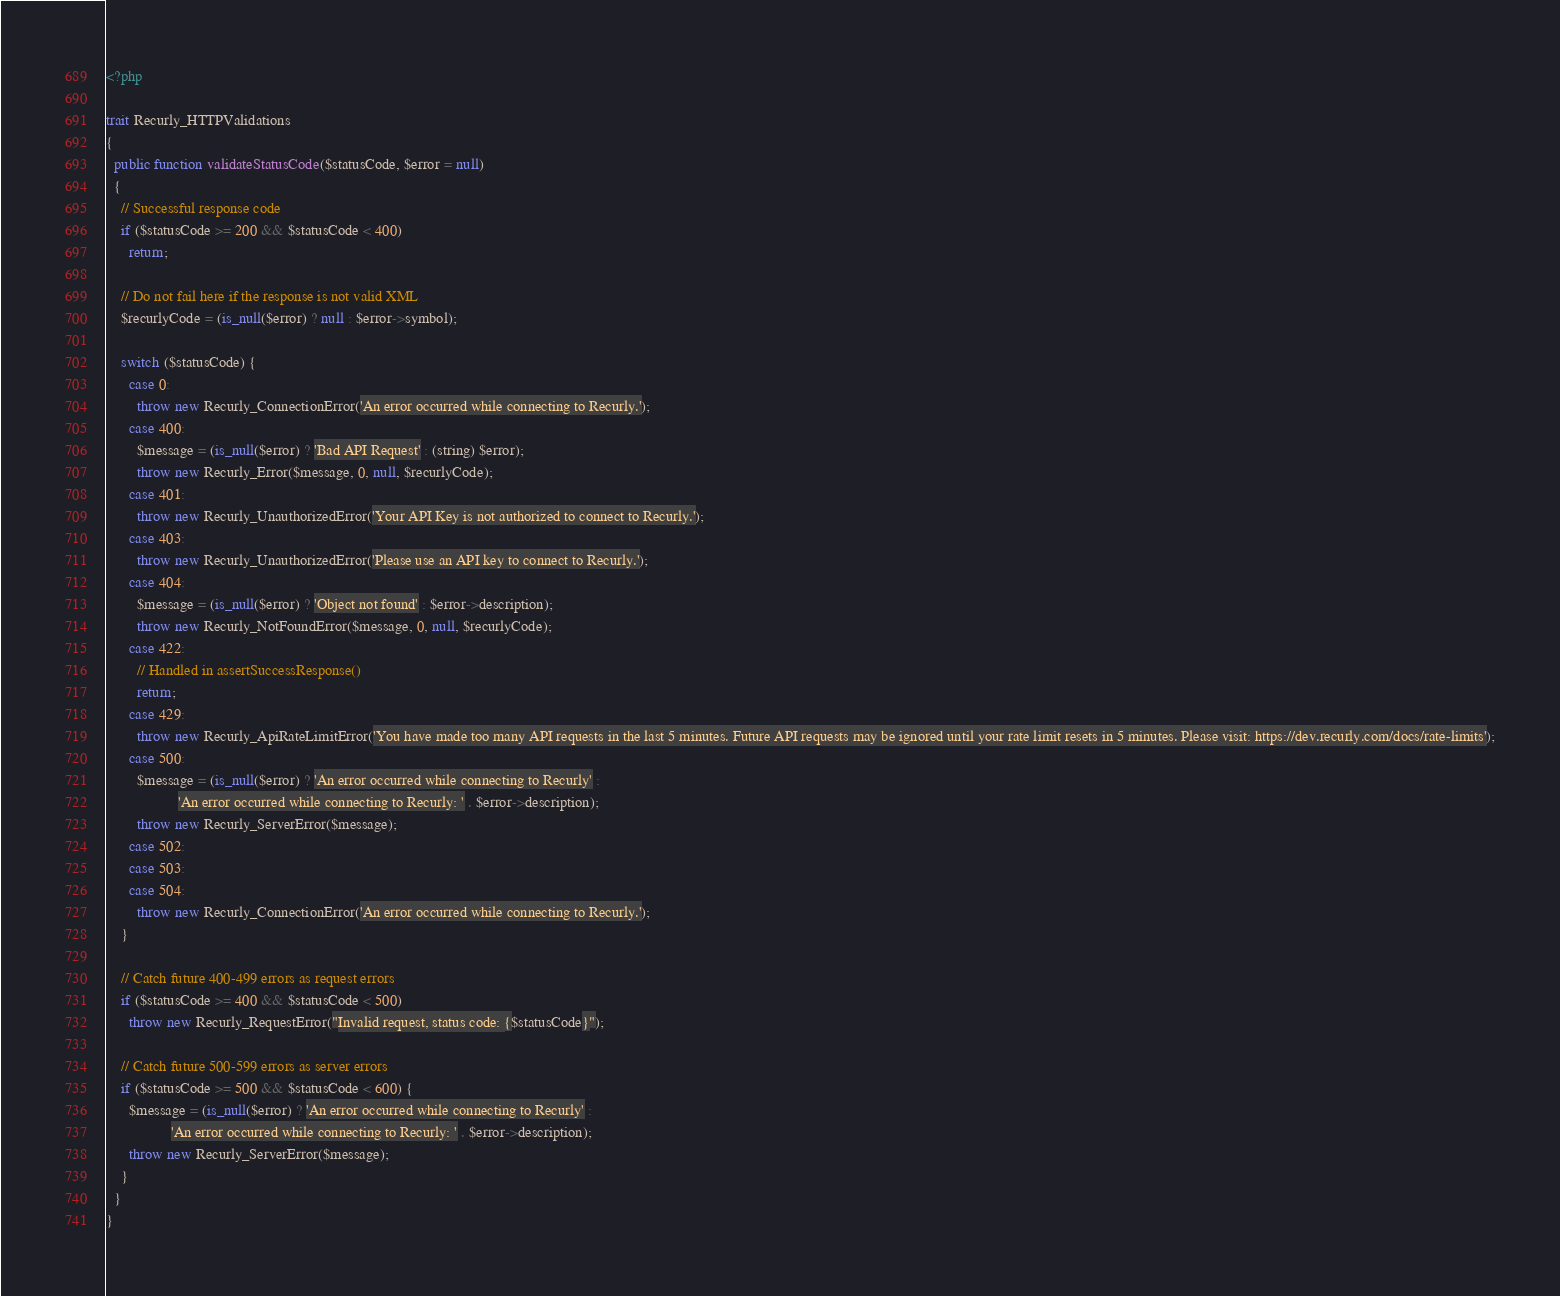Convert code to text. <code><loc_0><loc_0><loc_500><loc_500><_PHP_><?php

trait Recurly_HTTPValidations
{
  public function validateStatusCode($statusCode, $error = null)
  {
    // Successful response code
    if ($statusCode >= 200 && $statusCode < 400)
      return;

    // Do not fail here if the response is not valid XML
    $recurlyCode = (is_null($error) ? null : $error->symbol);

    switch ($statusCode) {
      case 0:
        throw new Recurly_ConnectionError('An error occurred while connecting to Recurly.');
      case 400:
        $message = (is_null($error) ? 'Bad API Request' : (string) $error);
        throw new Recurly_Error($message, 0, null, $recurlyCode);
      case 401:
        throw new Recurly_UnauthorizedError('Your API Key is not authorized to connect to Recurly.');
      case 403:
        throw new Recurly_UnauthorizedError('Please use an API key to connect to Recurly.');
      case 404:
        $message = (is_null($error) ? 'Object not found' : $error->description);
        throw new Recurly_NotFoundError($message, 0, null, $recurlyCode);
      case 422:
        // Handled in assertSuccessResponse()
        return;
      case 429:
        throw new Recurly_ApiRateLimitError('You have made too many API requests in the last 5 minutes. Future API requests may be ignored until your rate limit resets in 5 minutes. Please visit: https://dev.recurly.com/docs/rate-limits');
      case 500:
        $message = (is_null($error) ? 'An error occurred while connecting to Recurly' :
                   'An error occurred while connecting to Recurly: ' . $error->description);
        throw new Recurly_ServerError($message);
      case 502:
      case 503:
      case 504:
        throw new Recurly_ConnectionError('An error occurred while connecting to Recurly.');
    }

    // Catch future 400-499 errors as request errors
    if ($statusCode >= 400 && $statusCode < 500)
      throw new Recurly_RequestError("Invalid request, status code: {$statusCode}");

    // Catch future 500-599 errors as server errors
    if ($statusCode >= 500 && $statusCode < 600) {
      $message = (is_null($error) ? 'An error occurred while connecting to Recurly' :
                 'An error occurred while connecting to Recurly: ' . $error->description);
      throw new Recurly_ServerError($message);
    }
  }
}</code> 